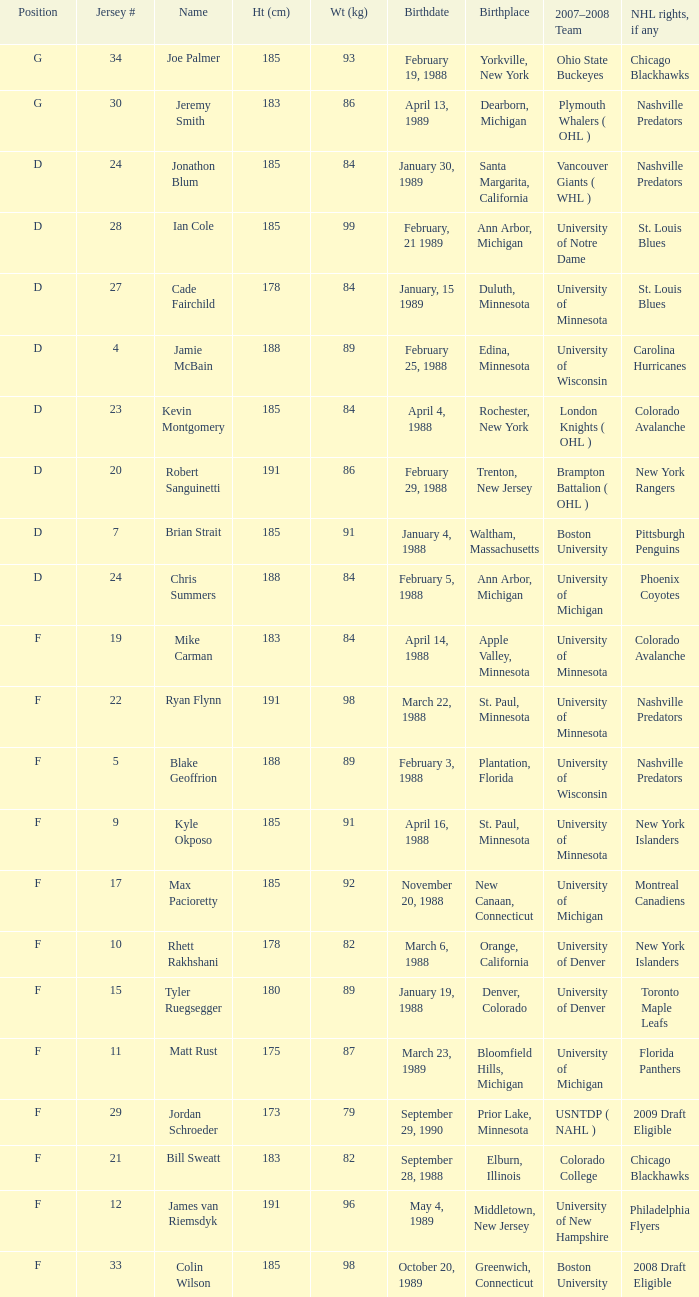Which Weight (kg) has a NHL rights, if any of phoenix coyotes? 1.0. 